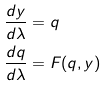Convert formula to latex. <formula><loc_0><loc_0><loc_500><loc_500>\frac { d y } { d \lambda } & = q \\ \frac { d q } { d \lambda } & = F ( q , y )</formula> 